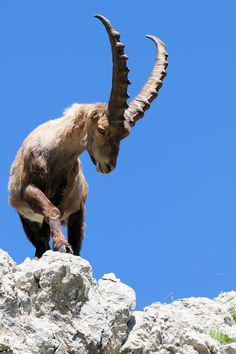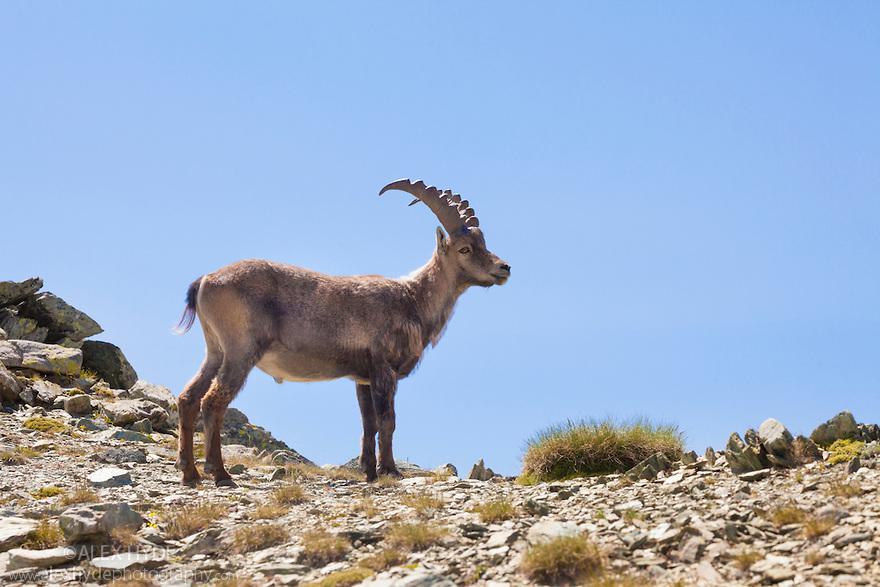The first image is the image on the left, the second image is the image on the right. Assess this claim about the two images: "The images show a single horned animal, and they face in different [left or right] directions.". Correct or not? Answer yes or no. No. The first image is the image on the left, the second image is the image on the right. Analyze the images presented: Is the assertion "Exactly one animal is facing to the left." valid? Answer yes or no. No. 